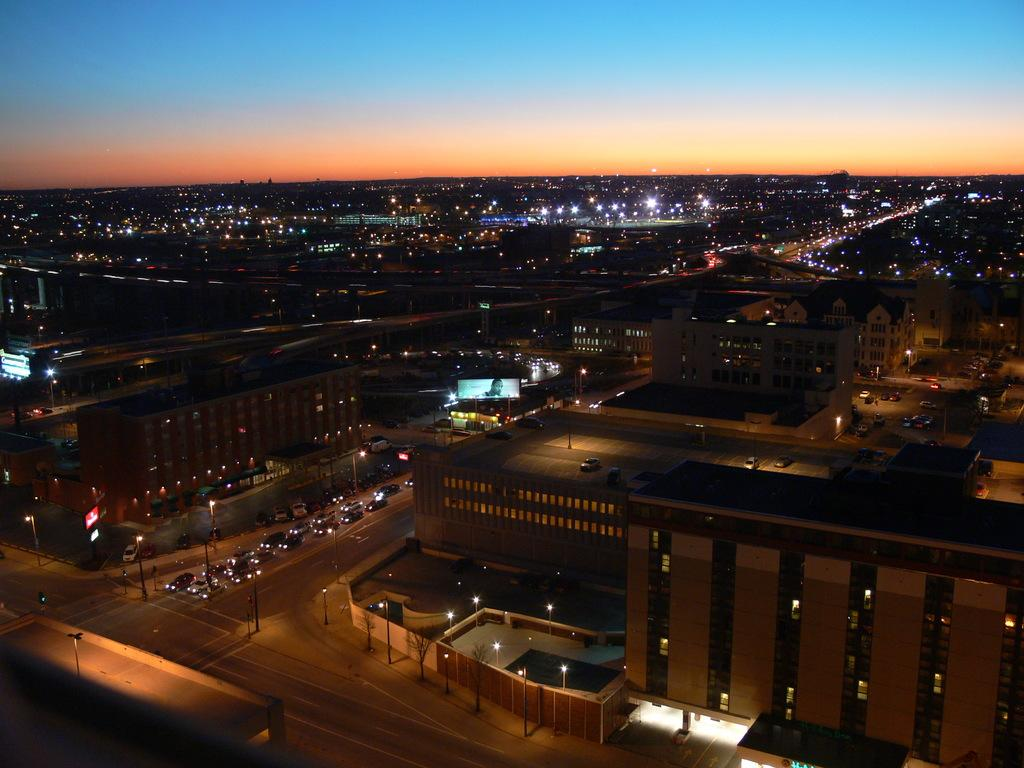What type of structures are present in the image? There are buildings in the image. What feature can be observed on the buildings? The buildings have glass windows. What else can be seen on the ground in the image? There are vehicles on the road in the image. What is visible at the top of the image? The sky is visible at the top of the image. Can you tell me how many cows are on the farm in the image? There is no farm or cows present in the image; it features buildings and vehicles on a road. 